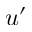<formula> <loc_0><loc_0><loc_500><loc_500>u ^ { \prime }</formula> 